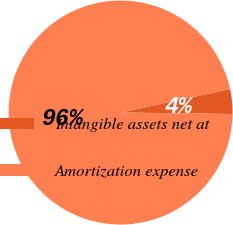Convert chart. <chart><loc_0><loc_0><loc_500><loc_500><pie_chart><fcel>Intangible assets net at<fcel>Amortization expense<nl><fcel>3.57%<fcel>96.43%<nl></chart> 